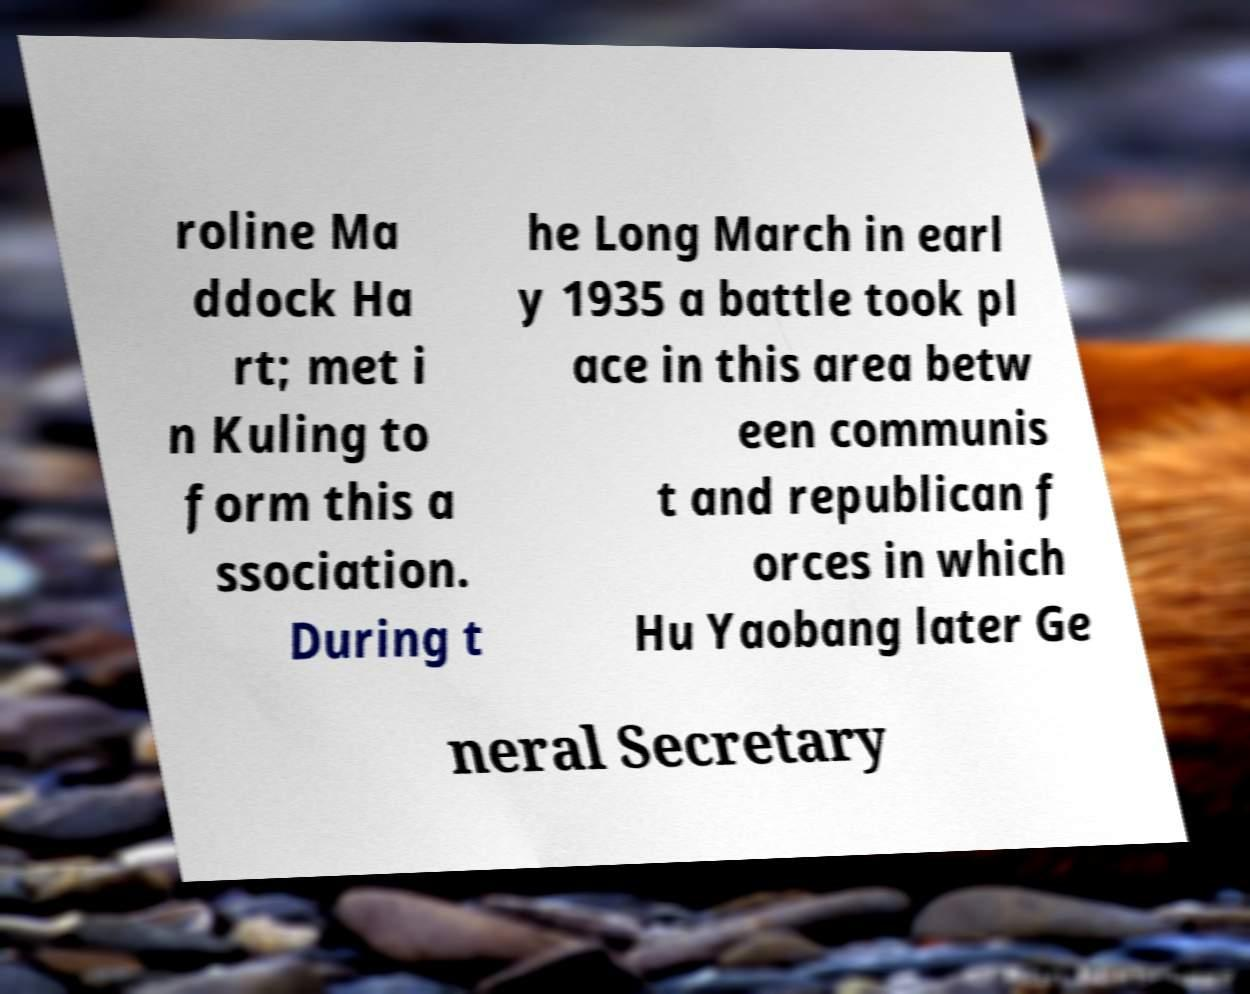I need the written content from this picture converted into text. Can you do that? roline Ma ddock Ha rt; met i n Kuling to form this a ssociation. During t he Long March in earl y 1935 a battle took pl ace in this area betw een communis t and republican f orces in which Hu Yaobang later Ge neral Secretary 